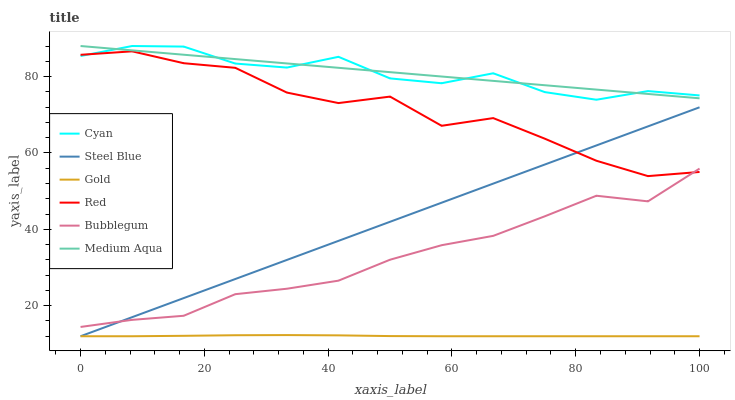Does Gold have the minimum area under the curve?
Answer yes or no. Yes. Does Medium Aqua have the maximum area under the curve?
Answer yes or no. Yes. Does Steel Blue have the minimum area under the curve?
Answer yes or no. No. Does Steel Blue have the maximum area under the curve?
Answer yes or no. No. Is Steel Blue the smoothest?
Answer yes or no. Yes. Is Red the roughest?
Answer yes or no. Yes. Is Bubblegum the smoothest?
Answer yes or no. No. Is Bubblegum the roughest?
Answer yes or no. No. Does Gold have the lowest value?
Answer yes or no. Yes. Does Bubblegum have the lowest value?
Answer yes or no. No. Does Cyan have the highest value?
Answer yes or no. Yes. Does Steel Blue have the highest value?
Answer yes or no. No. Is Red less than Medium Aqua?
Answer yes or no. Yes. Is Cyan greater than Gold?
Answer yes or no. Yes. Does Steel Blue intersect Red?
Answer yes or no. Yes. Is Steel Blue less than Red?
Answer yes or no. No. Is Steel Blue greater than Red?
Answer yes or no. No. Does Red intersect Medium Aqua?
Answer yes or no. No. 